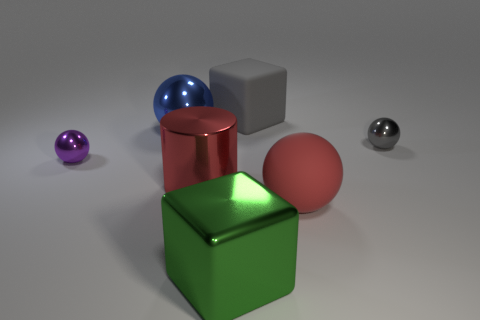What number of objects are big red shiny things in front of the tiny gray metal thing or small spheres that are to the left of the large cylinder?
Give a very brief answer. 2. There is a red cylinder that is made of the same material as the large green cube; what size is it?
Your response must be concise. Large. There is a shiny thing behind the small gray sphere; does it have the same shape as the red metallic thing?
Offer a terse response. No. What size is the thing that is the same color as the matte cube?
Provide a short and direct response. Small. How many cyan things are either shiny things or tiny metal objects?
Offer a terse response. 0. What number of other objects are there of the same shape as the large red matte thing?
Make the answer very short. 3. What shape is the big metal thing that is both behind the large green block and in front of the gray ball?
Provide a short and direct response. Cylinder. Are there any big matte things behind the big gray matte object?
Offer a terse response. No. The other thing that is the same shape as the large green thing is what size?
Keep it short and to the point. Large. Is the tiny gray thing the same shape as the large red metallic thing?
Your answer should be compact. No. 